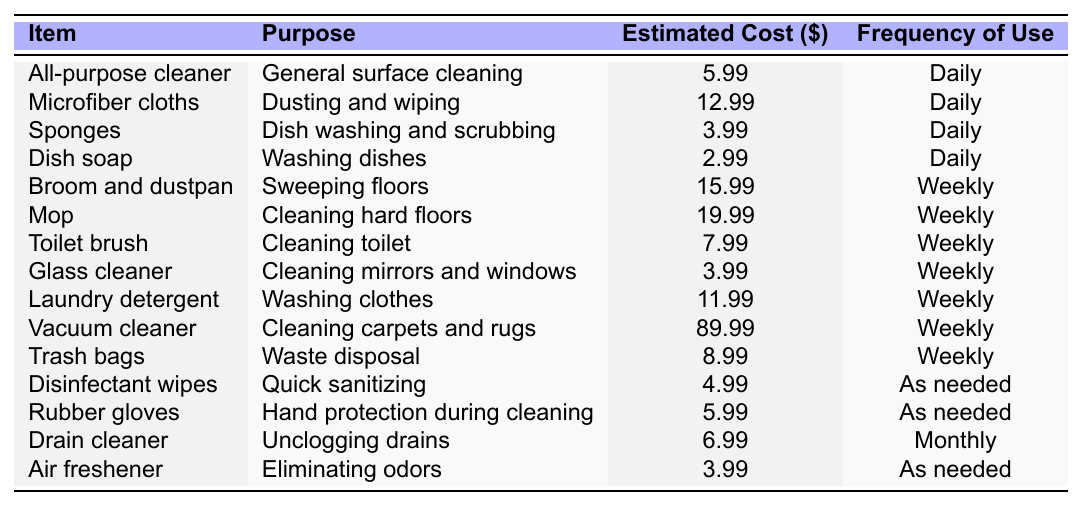What is the estimated cost of a mop? The table shows that the cost of a mop is listed under the "Estimated Cost ($)" column as 19.99.
Answer: 19.99 How often do you need to use disinfectant wipes? According to the "Frequency of Use" column, disinfectant wipes are used "As needed."
Answer: As needed Which item has the highest estimated cost? By examining the "Estimated Cost ($)" column, the vacuum cleaner has the highest price at 89.99.
Answer: Vacuum cleaner What is the total estimated cost of all the cleaning supplies listed? To find the total, add all the estimated costs: 5.99 + 12.99 + 3.99 + 2.99 + 15.99 + 19.99 + 7.99 + 3.99 + 11.99 + 89.99 + 8.99 + 4.99 + 5.99 + 6.99 + 3.99 =  49.96.
Answer: 211.83 Are rubber gloves used weekly? The table states that rubber gloves are used "As needed," not weekly. Therefore, the answer is no.
Answer: No What is the average cost of items that are used daily? The daily items are: All-purpose cleaner (5.99), Microfiber cloths (12.99), Sponges (3.99), Dish soap (2.99). The total cost is 5.99 + 12.99 + 3.99 + 2.99 = 25.96, and there are 4 items, so the average cost is 25.96 / 4 = 6.49.
Answer: 6.49 How many items are listed for monthly use? By reviewing the "Frequency of Use" column, only one item, Drain cleaner, is mentioned as used monthly.
Answer: 1 Is it true that glass cleaner is cheaper than air freshener? The table indicates glass cleaner costs 3.99 and air freshener also costs 3.99, meaning they are priced equally, so the statement is false.
Answer: No What is the total estimated cost of weekly used items? The weekly items are: Broom and dustpan (15.99), Mop (19.99), Toilet brush (7.99), Glass cleaner (3.99), Laundry detergent (11.99), Vacuum cleaner (89.99), Trash bags (8.99). Adding these gives a total of 15.99 + 19.99 + 7.99 + 3.99 + 11.99 + 89.99 + 8.99 = 157.92.
Answer: 157.92 